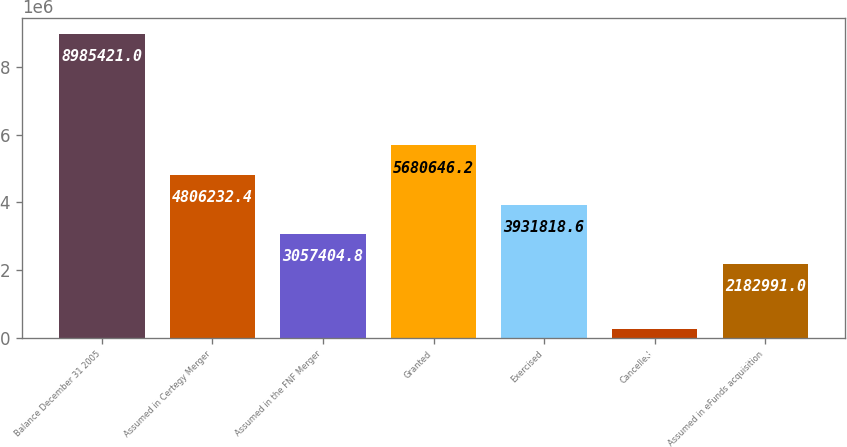Convert chart to OTSL. <chart><loc_0><loc_0><loc_500><loc_500><bar_chart><fcel>Balance December 31 2005<fcel>Assumed in Certegy Merger<fcel>Assumed in the FNF Merger<fcel>Granted<fcel>Exercised<fcel>Cancelled<fcel>Assumed in eFunds acquisition<nl><fcel>8.98542e+06<fcel>4.80623e+06<fcel>3.0574e+06<fcel>5.68065e+06<fcel>3.93182e+06<fcel>241283<fcel>2.18299e+06<nl></chart> 